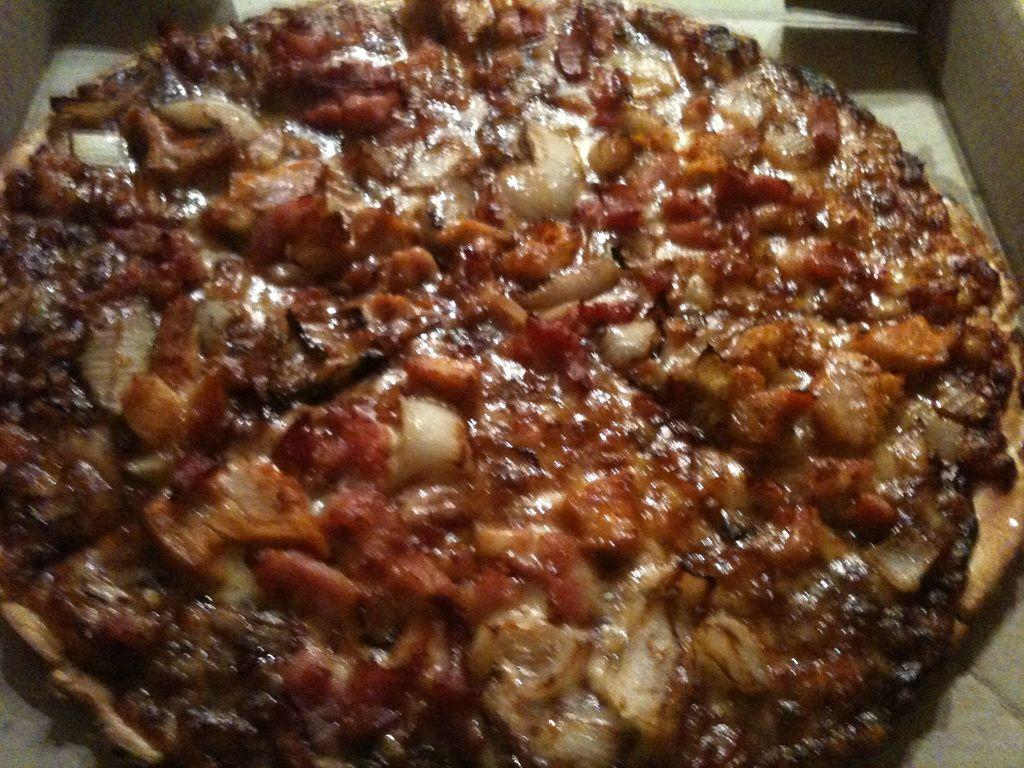What type of food is the main subject of the image? There is a pizza in the image. What toppings can be seen on the pizza? The pizza has veggies on it. What type of iron is visible in the image? There is no iron present in the image. Is there a coat hanging on the wall in the image? The provided facts do not mention a wall or a coat, so we cannot determine if there is a coat hanging on the wall in the image. Can you see a ray of light shining through the window in the image? The provided facts do not mention a window or a ray of light, so we cannot determine if there is a ray of light shining through the window in the image. 